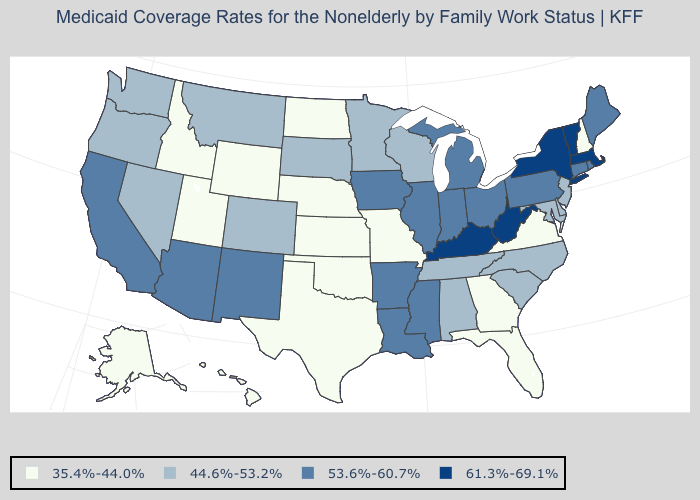What is the highest value in the USA?
Keep it brief. 61.3%-69.1%. Name the states that have a value in the range 35.4%-44.0%?
Be succinct. Alaska, Florida, Georgia, Hawaii, Idaho, Kansas, Missouri, Nebraska, New Hampshire, North Dakota, Oklahoma, Texas, Utah, Virginia, Wyoming. Which states have the lowest value in the USA?
Quick response, please. Alaska, Florida, Georgia, Hawaii, Idaho, Kansas, Missouri, Nebraska, New Hampshire, North Dakota, Oklahoma, Texas, Utah, Virginia, Wyoming. What is the value of Pennsylvania?
Answer briefly. 53.6%-60.7%. Which states hav the highest value in the MidWest?
Keep it brief. Illinois, Indiana, Iowa, Michigan, Ohio. Does Missouri have the lowest value in the MidWest?
Short answer required. Yes. What is the highest value in states that border Mississippi?
Keep it brief. 53.6%-60.7%. Among the states that border South Carolina , which have the lowest value?
Concise answer only. Georgia. Among the states that border Montana , does South Dakota have the lowest value?
Quick response, please. No. Name the states that have a value in the range 44.6%-53.2%?
Write a very short answer. Alabama, Colorado, Delaware, Maryland, Minnesota, Montana, Nevada, New Jersey, North Carolina, Oregon, South Carolina, South Dakota, Tennessee, Washington, Wisconsin. Which states have the lowest value in the West?
Short answer required. Alaska, Hawaii, Idaho, Utah, Wyoming. Does Rhode Island have the same value as North Carolina?
Give a very brief answer. No. Name the states that have a value in the range 53.6%-60.7%?
Give a very brief answer. Arizona, Arkansas, California, Connecticut, Illinois, Indiana, Iowa, Louisiana, Maine, Michigan, Mississippi, New Mexico, Ohio, Pennsylvania, Rhode Island. Does Indiana have the lowest value in the USA?
Short answer required. No. 